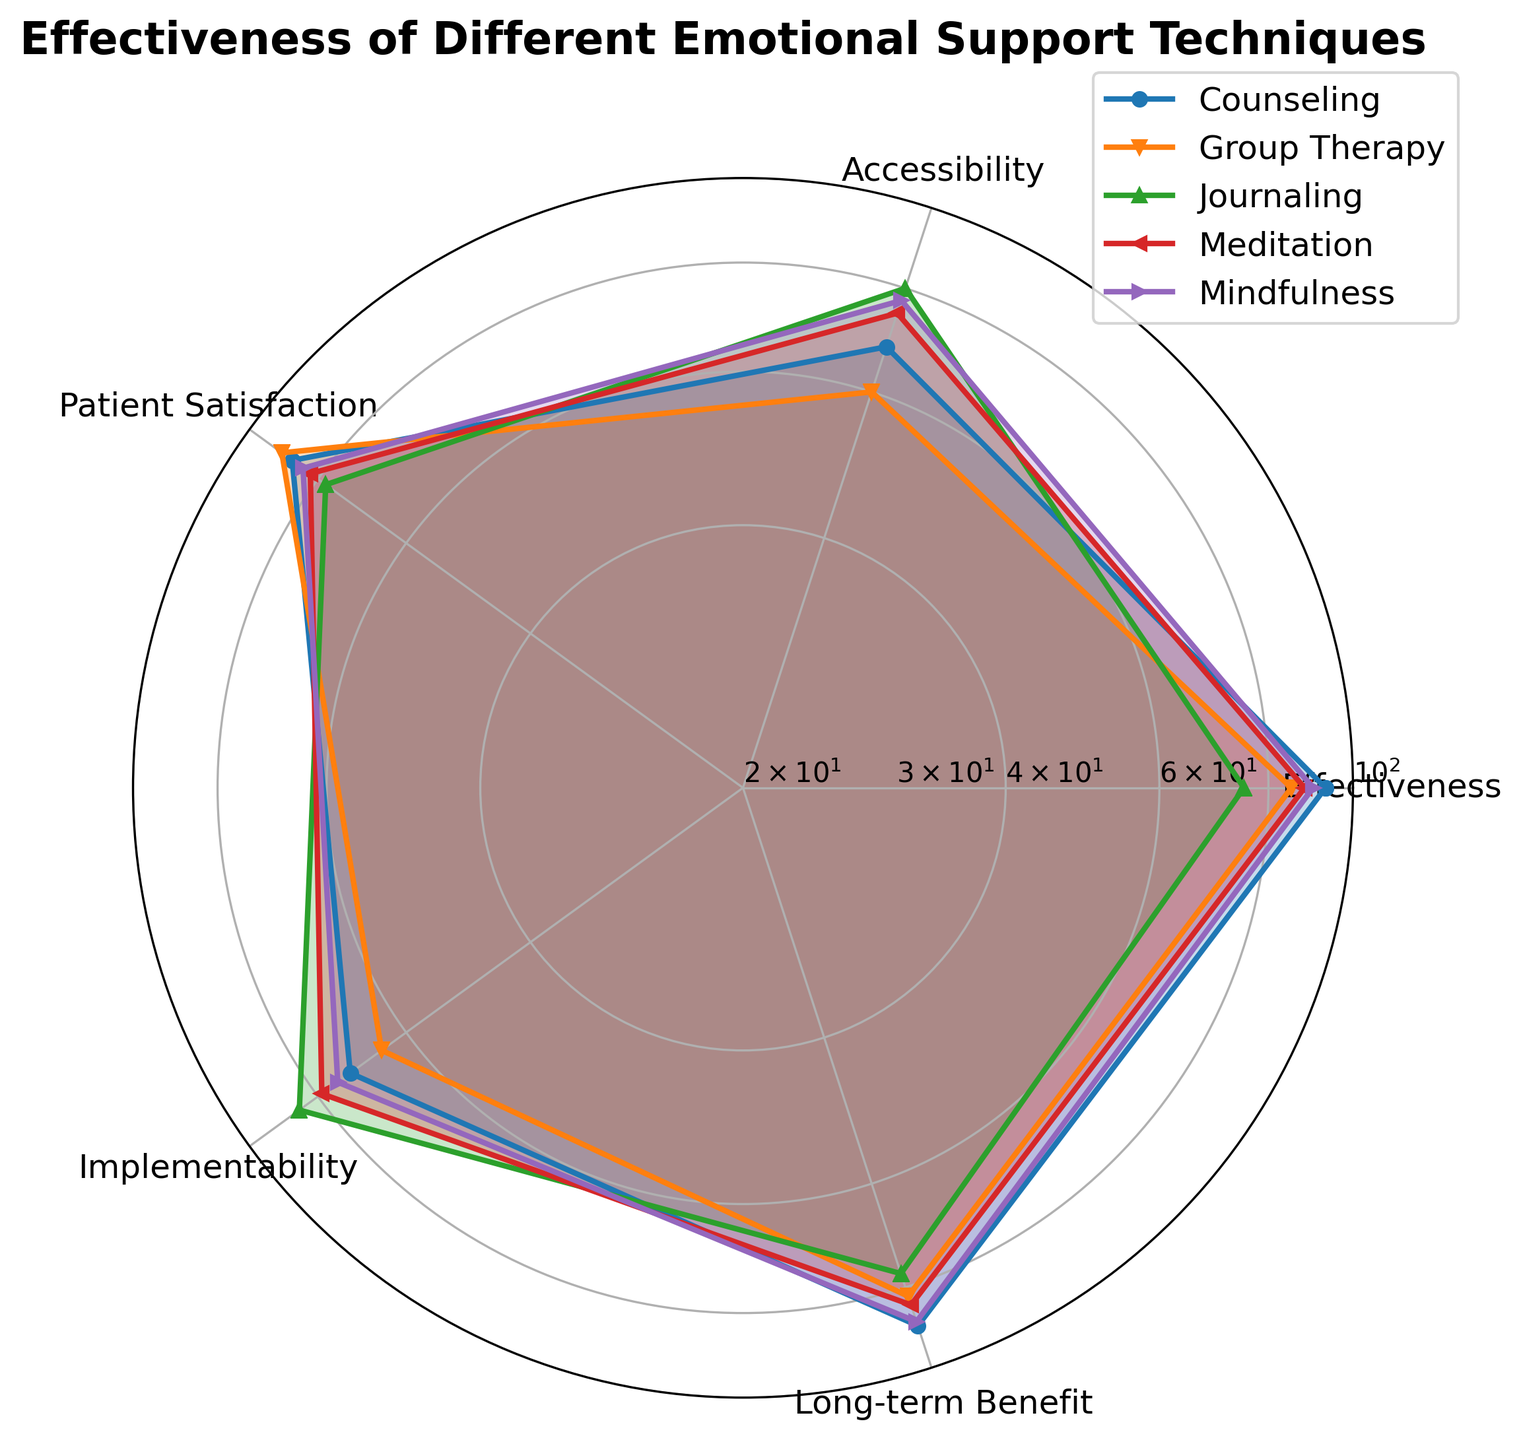What is the most effective technique for emotional support according to the chart? The effectiveness is highest for the technique with the largest value on the 'Effectiveness' axis. Looking at the outermost line on this axis, Counseling shows the highest value.
Answer: Counseling Which technique has the highest patient satisfaction? The technique with the highest patient satisfaction will have its value line reaching the farthest point on the 'Patient Satisfaction' axis. This is Group Therapy.
Answer: Group Therapy Among Meditation and Journaling, which technique is more accessible? By comparing the points for 'Accessibility' on the chart for Meditation and Journaling, Journaling is shown to be more accessible based on the data points.
Answer: Journaling Does Group Therapy have higher long-term benefits than Meditation? By looking at the data points for 'Long-term Benefit' on the chart for both techniques, Group Therapy and Meditation are compared. Meditation has a higher value.
Answer: No Which technique is the easiest to implement overall? The Implementability axis should be observed for all techniques; the further out the value line is, the easier it is to implement. Journaling features the highest value in Implementability.
Answer: Journaling What's the average effectiveness score of all the techniques combined? To find the average, sum up the mean effectiveness scores of all techniques and divide by the number of techniques: (88+93+75+85+90)/5 = 86.2
Answer: 86.2 Which technique has the least variation in values across all attributes? By observing the consistency of the value lines for each technique across all axes, Mindfulness shows the least variation as its values are relatively uniform across the chart.
Answer: Mindfulness Is Journaling more beneficial in the long term than Counseling? Looking at the 'Long-term Benefit' axis, compare the values of Journaling and Counseling. Counseling has a higher value than Journaling.
Answer: No Out of Group Therapy and Mindfulness, which one scores lower on accessibility? Comparing the 'Accessibility' values between Group Therapy and Mindfulness, Group Therapy has a lower value.
Answer: Group Therapy How does the patient satisfaction of Counseling compare to that of Mindfulness? Compare the values on the 'Patient Satisfaction' axis for Counseling and Mindfulness. Mindfulness has slightly lower patient satisfaction compared to Counseling.
Answer: Counseling is higher 